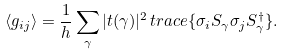Convert formula to latex. <formula><loc_0><loc_0><loc_500><loc_500>\langle g _ { i j } \rangle = \frac { 1 } { h } \sum _ { \gamma } | t ( \gamma ) | ^ { 2 } \, t r a c e \{ \sigma _ { i } S _ { \gamma } \sigma _ { j } S _ { \gamma } ^ { \dagger } \} .</formula> 